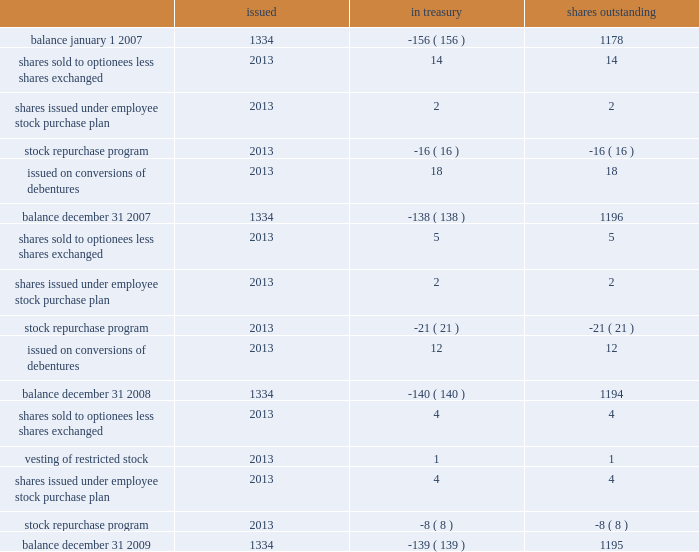Part ii , item 8 schlumberger limited and subsidiaries shares of common stock ( stated in millions ) issued in treasury shares outstanding .
See the notes to consolidated financial statements .
If shares increase in the same amount as 2008 , what is the expected balance at the end of 2009? 
Computations: ((1195 + (1195 - 1194)) * 1000000)
Answer: 1196000000.0. 